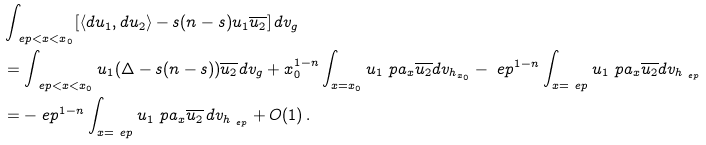Convert formula to latex. <formula><loc_0><loc_0><loc_500><loc_500>& \int _ { \ e p < x < x _ { 0 } } [ \langle d u _ { 1 } , d u _ { 2 } \rangle - s ( n - s ) u _ { 1 } \overline { u _ { 2 } } ] \, d v _ { g } \\ & = \int _ { \ e p < x < x _ { 0 } } u _ { 1 } ( \Delta - s ( n - s ) ) \overline { u _ { 2 } } d v _ { g } + x _ { 0 } ^ { 1 - n } \int _ { x = x _ { 0 } } u _ { 1 } \ p a _ { x } \overline { u _ { 2 } } d v _ { h _ { x _ { 0 } } } - \ e p ^ { 1 - n } \int _ { x = \ e p } u _ { 1 } \ p a _ { x } \overline { u _ { 2 } } d v _ { h _ { \ e p } } \\ & = - \ e p ^ { 1 - n } \int _ { x = \ e p } u _ { 1 } \ p a _ { x } \overline { u _ { 2 } } \, d v _ { h _ { \ e p } } + O ( 1 ) \, .</formula> 